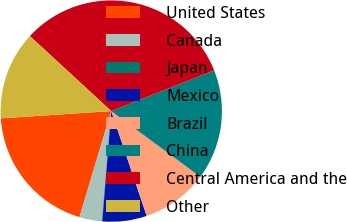Convert chart to OTSL. <chart><loc_0><loc_0><loc_500><loc_500><pie_chart><fcel>United States<fcel>Canada<fcel>Japan<fcel>Mexico<fcel>Brazil<fcel>China<fcel>Central America and the<fcel>Other<nl><fcel>19.32%<fcel>3.28%<fcel>0.07%<fcel>6.48%<fcel>9.69%<fcel>16.11%<fcel>32.15%<fcel>12.9%<nl></chart> 